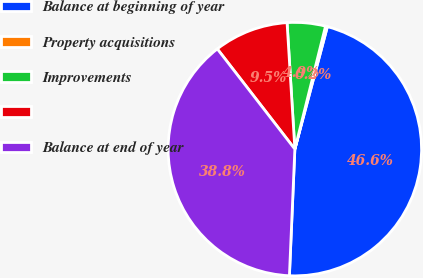Convert chart to OTSL. <chart><loc_0><loc_0><loc_500><loc_500><pie_chart><fcel>Balance at beginning of year<fcel>Property acquisitions<fcel>Improvements<fcel>Unnamed: 3<fcel>Balance at end of year<nl><fcel>46.55%<fcel>0.24%<fcel>4.87%<fcel>9.5%<fcel>38.83%<nl></chart> 